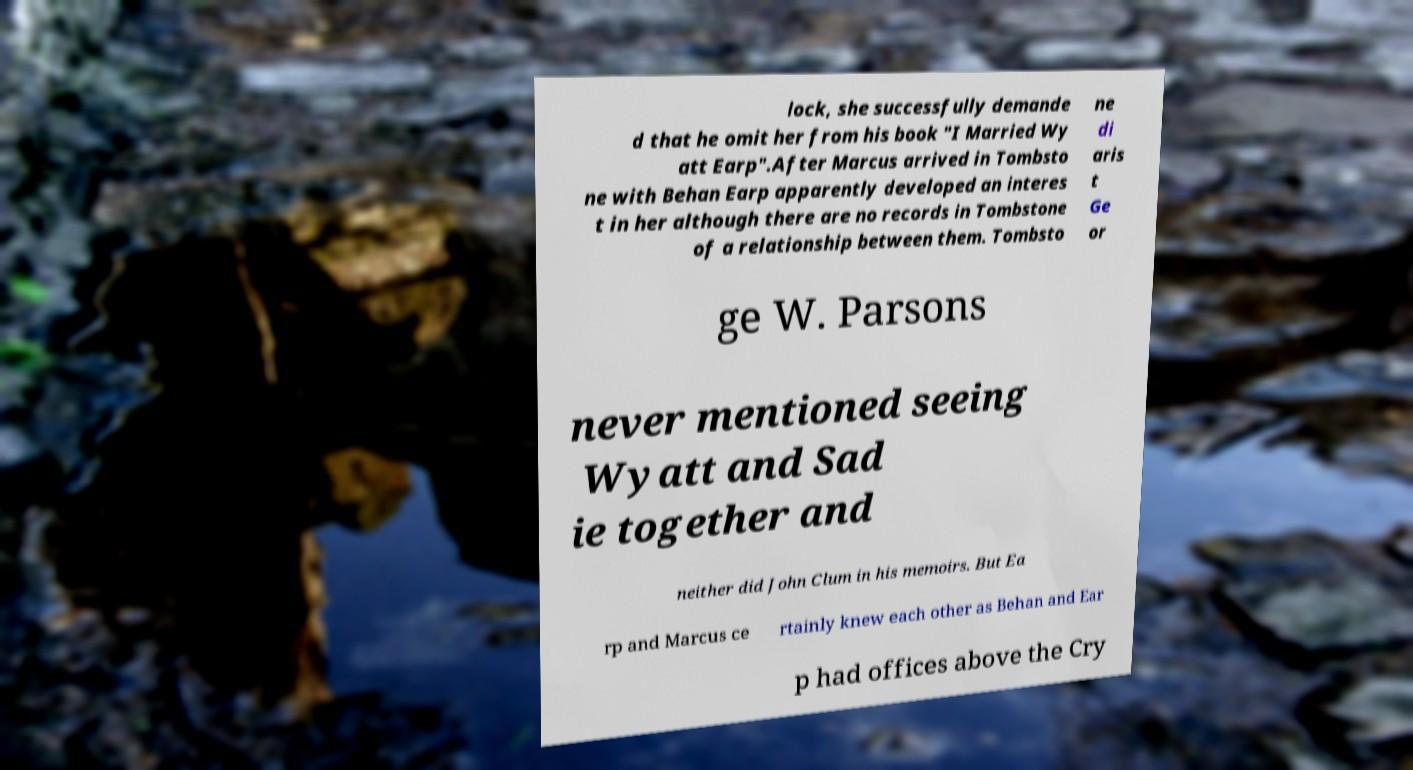What messages or text are displayed in this image? I need them in a readable, typed format. lock, she successfully demande d that he omit her from his book "I Married Wy att Earp".After Marcus arrived in Tombsto ne with Behan Earp apparently developed an interes t in her although there are no records in Tombstone of a relationship between them. Tombsto ne di aris t Ge or ge W. Parsons never mentioned seeing Wyatt and Sad ie together and neither did John Clum in his memoirs. But Ea rp and Marcus ce rtainly knew each other as Behan and Ear p had offices above the Cry 